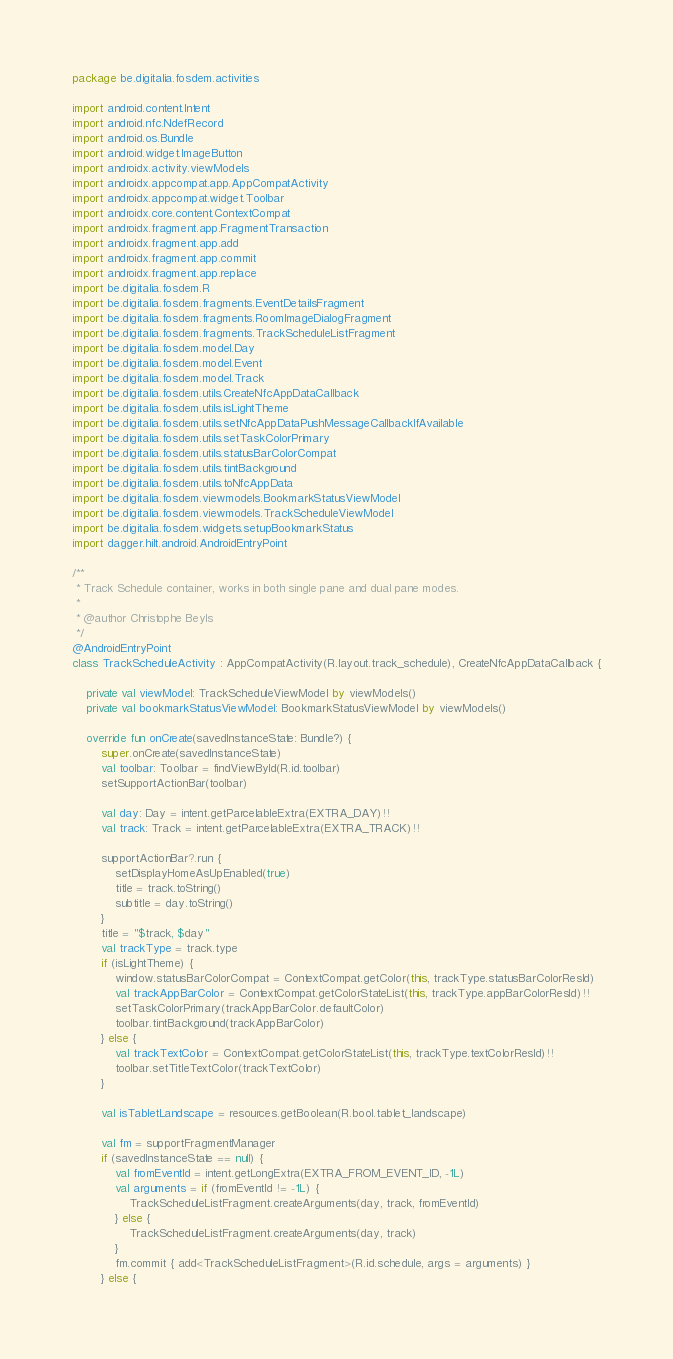Convert code to text. <code><loc_0><loc_0><loc_500><loc_500><_Kotlin_>package be.digitalia.fosdem.activities

import android.content.Intent
import android.nfc.NdefRecord
import android.os.Bundle
import android.widget.ImageButton
import androidx.activity.viewModels
import androidx.appcompat.app.AppCompatActivity
import androidx.appcompat.widget.Toolbar
import androidx.core.content.ContextCompat
import androidx.fragment.app.FragmentTransaction
import androidx.fragment.app.add
import androidx.fragment.app.commit
import androidx.fragment.app.replace
import be.digitalia.fosdem.R
import be.digitalia.fosdem.fragments.EventDetailsFragment
import be.digitalia.fosdem.fragments.RoomImageDialogFragment
import be.digitalia.fosdem.fragments.TrackScheduleListFragment
import be.digitalia.fosdem.model.Day
import be.digitalia.fosdem.model.Event
import be.digitalia.fosdem.model.Track
import be.digitalia.fosdem.utils.CreateNfcAppDataCallback
import be.digitalia.fosdem.utils.isLightTheme
import be.digitalia.fosdem.utils.setNfcAppDataPushMessageCallbackIfAvailable
import be.digitalia.fosdem.utils.setTaskColorPrimary
import be.digitalia.fosdem.utils.statusBarColorCompat
import be.digitalia.fosdem.utils.tintBackground
import be.digitalia.fosdem.utils.toNfcAppData
import be.digitalia.fosdem.viewmodels.BookmarkStatusViewModel
import be.digitalia.fosdem.viewmodels.TrackScheduleViewModel
import be.digitalia.fosdem.widgets.setupBookmarkStatus
import dagger.hilt.android.AndroidEntryPoint

/**
 * Track Schedule container, works in both single pane and dual pane modes.
 *
 * @author Christophe Beyls
 */
@AndroidEntryPoint
class TrackScheduleActivity : AppCompatActivity(R.layout.track_schedule), CreateNfcAppDataCallback {

    private val viewModel: TrackScheduleViewModel by viewModels()
    private val bookmarkStatusViewModel: BookmarkStatusViewModel by viewModels()

    override fun onCreate(savedInstanceState: Bundle?) {
        super.onCreate(savedInstanceState)
        val toolbar: Toolbar = findViewById(R.id.toolbar)
        setSupportActionBar(toolbar)

        val day: Day = intent.getParcelableExtra(EXTRA_DAY)!!
        val track: Track = intent.getParcelableExtra(EXTRA_TRACK)!!

        supportActionBar?.run {
            setDisplayHomeAsUpEnabled(true)
            title = track.toString()
            subtitle = day.toString()
        }
        title = "$track, $day"
        val trackType = track.type
        if (isLightTheme) {
            window.statusBarColorCompat = ContextCompat.getColor(this, trackType.statusBarColorResId)
            val trackAppBarColor = ContextCompat.getColorStateList(this, trackType.appBarColorResId)!!
            setTaskColorPrimary(trackAppBarColor.defaultColor)
            toolbar.tintBackground(trackAppBarColor)
        } else {
            val trackTextColor = ContextCompat.getColorStateList(this, trackType.textColorResId)!!
            toolbar.setTitleTextColor(trackTextColor)
        }

        val isTabletLandscape = resources.getBoolean(R.bool.tablet_landscape)

        val fm = supportFragmentManager
        if (savedInstanceState == null) {
            val fromEventId = intent.getLongExtra(EXTRA_FROM_EVENT_ID, -1L)
            val arguments = if (fromEventId != -1L) {
                TrackScheduleListFragment.createArguments(day, track, fromEventId)
            } else {
                TrackScheduleListFragment.createArguments(day, track)
            }
            fm.commit { add<TrackScheduleListFragment>(R.id.schedule, args = arguments) }
        } else {</code> 